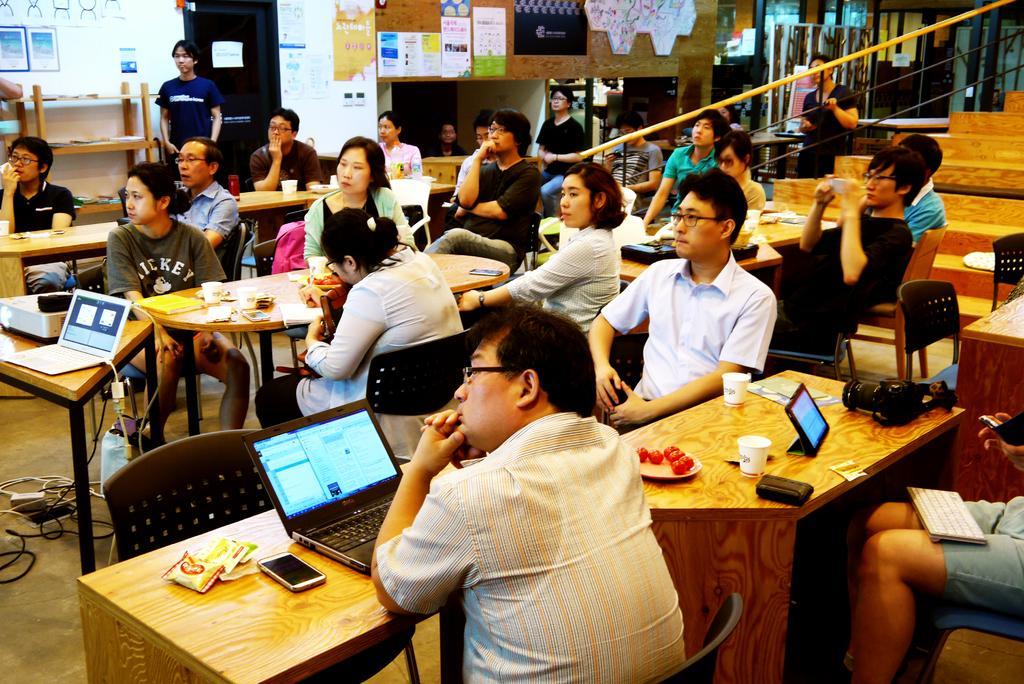Could you give a brief overview of what you see in this image? there are many people sitting on the chair and watching towards the left. on the table there are laptops and phones. at the right corner there are stairs. at the back there are paper notes and door. 